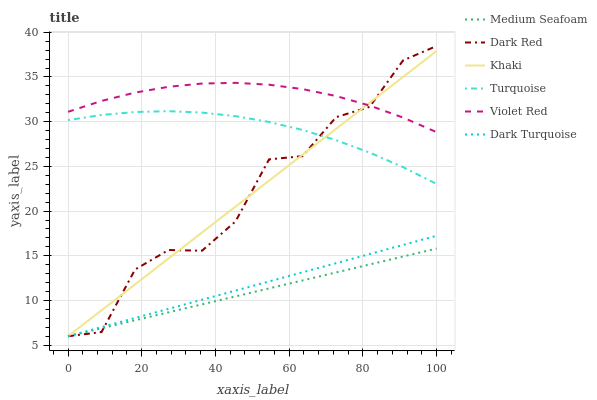Does Medium Seafoam have the minimum area under the curve?
Answer yes or no. Yes. Does Violet Red have the maximum area under the curve?
Answer yes or no. Yes. Does Khaki have the minimum area under the curve?
Answer yes or no. No. Does Khaki have the maximum area under the curve?
Answer yes or no. No. Is Medium Seafoam the smoothest?
Answer yes or no. Yes. Is Dark Red the roughest?
Answer yes or no. Yes. Is Khaki the smoothest?
Answer yes or no. No. Is Khaki the roughest?
Answer yes or no. No. Does Violet Red have the lowest value?
Answer yes or no. No. Does Dark Red have the highest value?
Answer yes or no. Yes. Does Khaki have the highest value?
Answer yes or no. No. Is Medium Seafoam less than Violet Red?
Answer yes or no. Yes. Is Violet Red greater than Medium Seafoam?
Answer yes or no. Yes. Does Turquoise intersect Dark Red?
Answer yes or no. Yes. Is Turquoise less than Dark Red?
Answer yes or no. No. Is Turquoise greater than Dark Red?
Answer yes or no. No. Does Medium Seafoam intersect Violet Red?
Answer yes or no. No. 